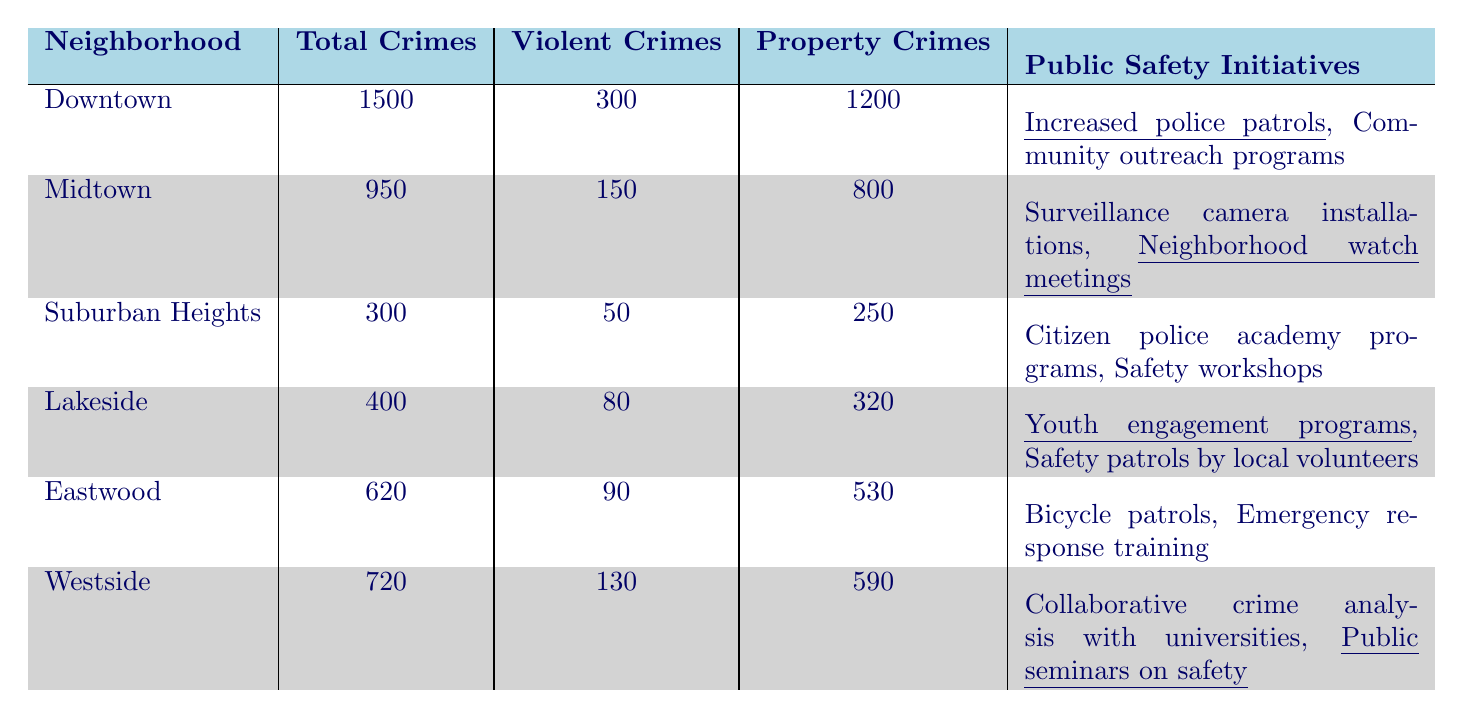What is the total number of crimes recorded in Downtown? The table shows "Total Crimes" for Downtown as 1500.
Answer: 1500 Which neighborhood has the highest number of property crimes? By comparing "Property Crimes," Downtown has 1200 while Midtown has 800, Suburban Heights has 250, Lakeside has 320, Eastwood has 530, and Westside has 590. Therefore, Downtown has the highest.
Answer: Downtown How many violent crimes were reported in Midtown? The table lists "Violent Crimes" for Midtown as 150.
Answer: 150 What is the difference in total crimes between Eastwood and Lakeside? Eastwood has 620 total crimes and Lakeside has 400. The difference is 620 - 400 = 220.
Answer: 220 What percentage of crimes in the Suburban Heights are violent? Suburban Heights has a total of 300 crimes and 50 of them are violent. To find the percentage, (50/300) * 100 = 16.67%.
Answer: 16.67% Are there more total crimes in Lakeside than in Midtown? Lakeside has 400 total crimes, while Midtown has 950 total crimes, making the statement false.
Answer: No Which neighborhood has the lowest number of total crimes? Comparing the "Total Crimes," Suburban Heights has the lowest total at 300.
Answer: Suburban Heights What is the combined number of violent crimes in Downtown and Westside? Downtown has 300 violent crimes and Westside has 130. The sum is 300 + 130 = 430.
Answer: 430 Do all neighborhoods implement public safety initiatives? Each neighborhood mentioned in the table has at least one public safety initiative listed, so the answer is yes.
Answer: Yes If we combine the property crimes from Midtown, Eastwood, and Lakeside, what is the total? Midtown has 800, Eastwood has 530, and Lakeside has 320. Adding them gives 800 + 530 + 320 = 1650.
Answer: 1650 